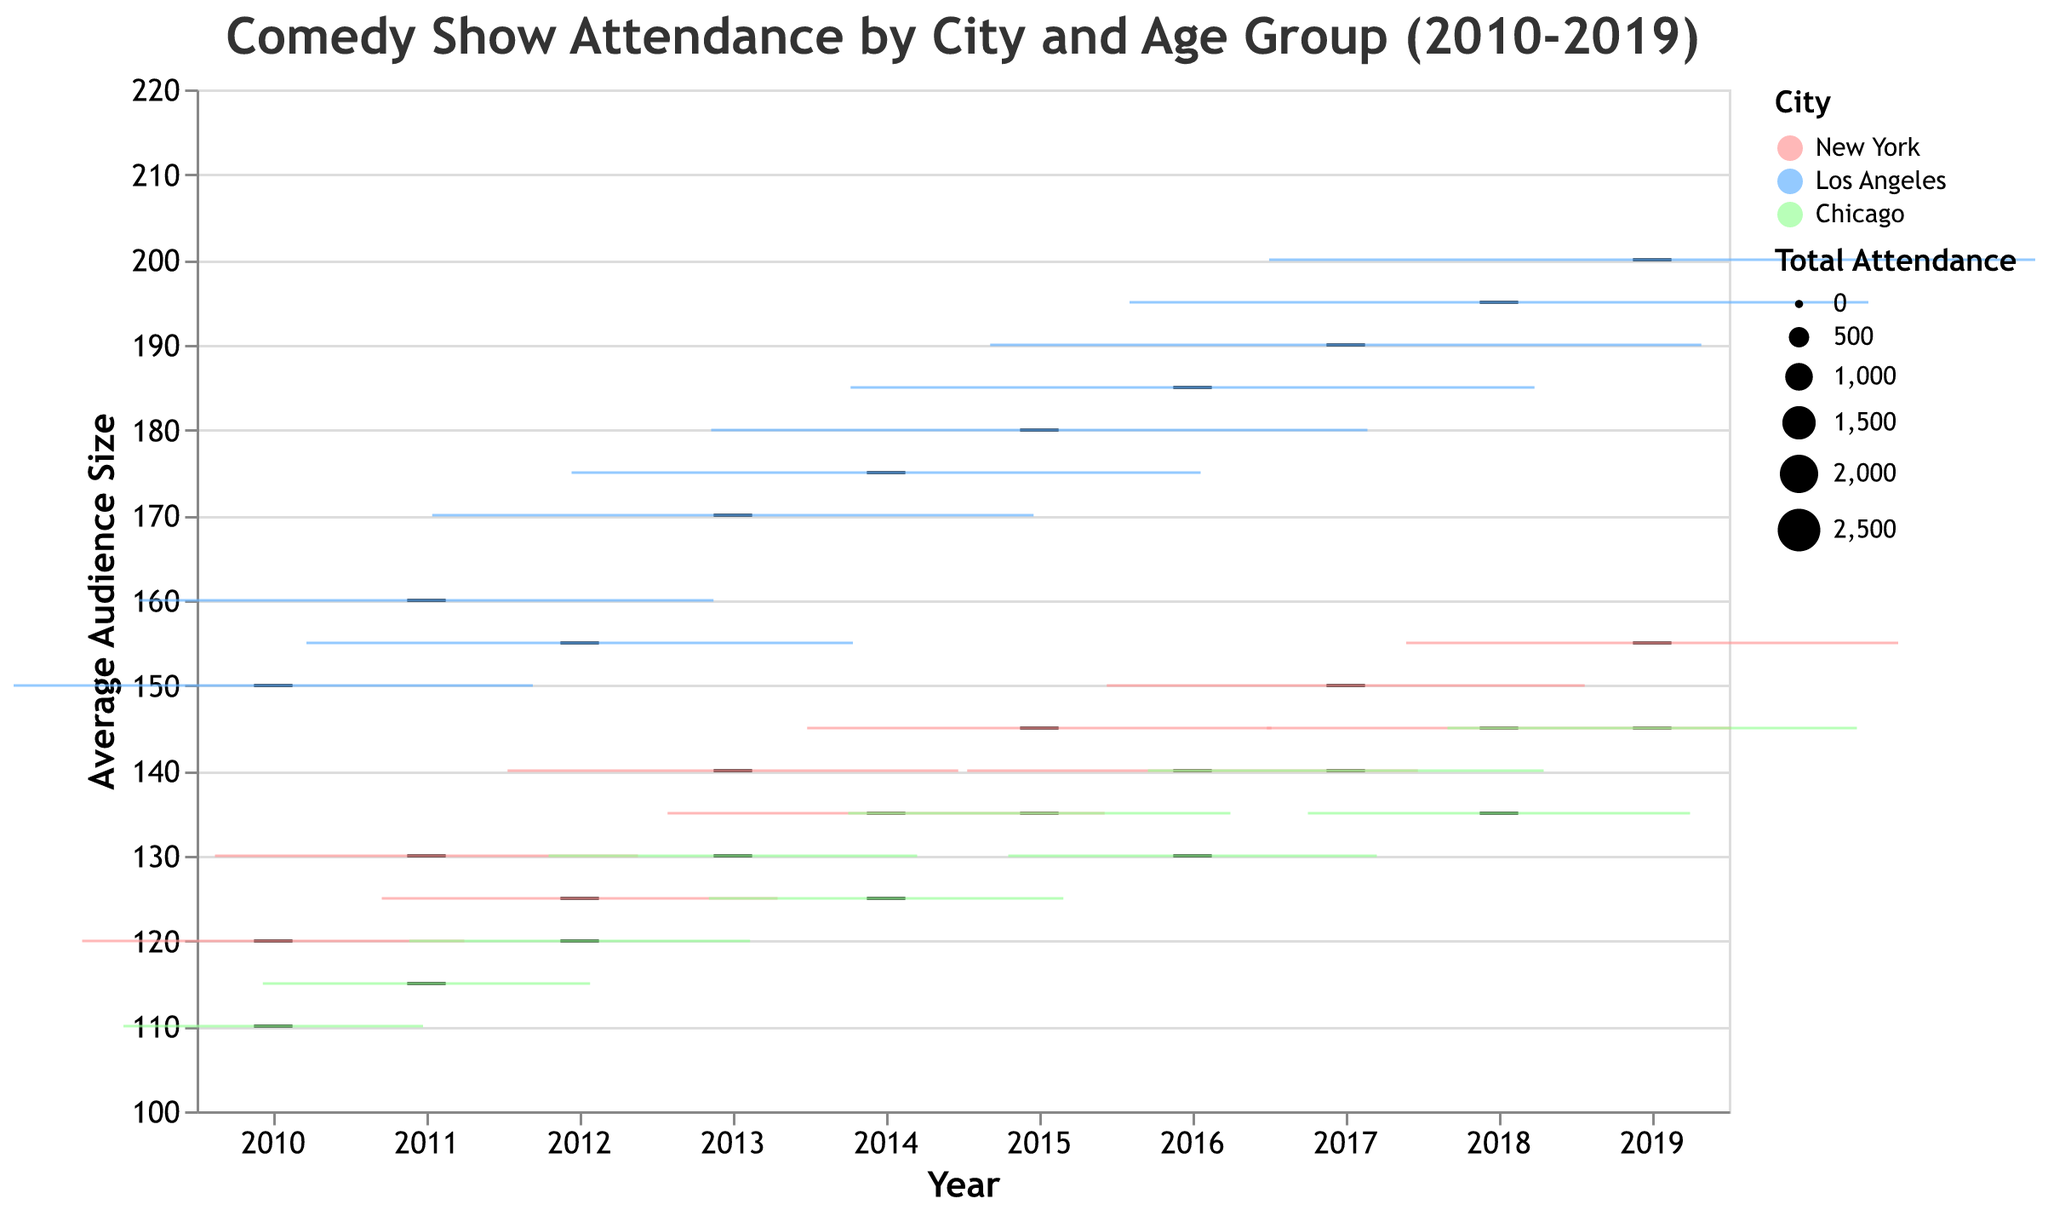What is the most frequent age group for the New York shows from 2010 to 2019? The figure shows the cities and the age groups over the years. By looking at the New York section, we see that the age group 18-24 appears consistently every year from 2010 to 2019.
Answer: 18-24 What is the trend of the average audience size for Los Angeles shows between 2010 and 2019? Observing the Los Angeles box plots, we see a general increasing trend in the average audience size from 150 in 2010 to around 200 in 2019.
Answer: Increasing trend Which city had the largest average audience size in 2019? To determine the city with the largest average audience size in 2019, compare the highest points of the box plots for each city in that year. Los Angeles has the highest average audience size, around 200.
Answer: Los Angeles What was the lowest average audience size recorded in Chicago from 2010 to 2019? Looking specifically at the Chicago data, the lowest point on any box plot corresponds to around 110 in 2010.
Answer: 110 In 2015, how does the median audience size for New York compare to the median audience size for Los Angeles? Look at the median lines inside the box plots for New York and Los Angeles in 2015. New York's median is at 145, while Los Angeles's median is higher at 180. Therefore, Los Angeles has a higher median audience size in 2015.
Answer: Los Angeles has a higher median What age group had the smallest average audience size in 2013 across all cities? Compare the lowest points of the box plots for 2013 across all cities and age groups. The 35-44 age group in Chicago has the lowest average audience size of about 130.
Answer: Chicago's 35-44 group By how much did the average audience size increase for the New York 18-24 age group from 2010 to 2019? The average audience size in New York for the 18-24 age group was 120 in 2010 and 155 in 2019. The increase is 155 - 120 = 35.
Answer: 35 Which city saw the most significant growth in total attendance numbers from 2010 to 2019? Compare the widths of the box plots over the years, representing total attendance numbers. Los Angeles shows a substantial increase in box plot width, indicating the largest growth in attendance.
Answer: Los Angeles How does the interquartile range of the average audience size for Chicago in 2017 compare to that in 2011? By examining the height of the boxes (indicating the IQR) for Chicago in both years, we see that Chicago in 2017 has a larger IQR than in 2011, indicating more variability in audience size.
Answer: Larger in 2017 What is the overall median average audience size across all years and cities? Identify and compare the median lines within each city's box plot for every year. The median values hover around 150 for all cities, making it the overall median.
Answer: 150 